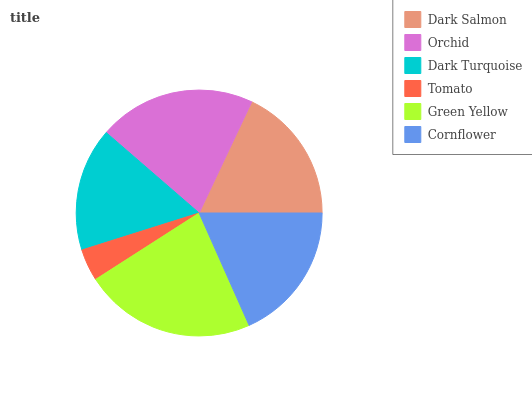Is Tomato the minimum?
Answer yes or no. Yes. Is Green Yellow the maximum?
Answer yes or no. Yes. Is Orchid the minimum?
Answer yes or no. No. Is Orchid the maximum?
Answer yes or no. No. Is Orchid greater than Dark Salmon?
Answer yes or no. Yes. Is Dark Salmon less than Orchid?
Answer yes or no. Yes. Is Dark Salmon greater than Orchid?
Answer yes or no. No. Is Orchid less than Dark Salmon?
Answer yes or no. No. Is Cornflower the high median?
Answer yes or no. Yes. Is Dark Salmon the low median?
Answer yes or no. Yes. Is Dark Salmon the high median?
Answer yes or no. No. Is Dark Turquoise the low median?
Answer yes or no. No. 